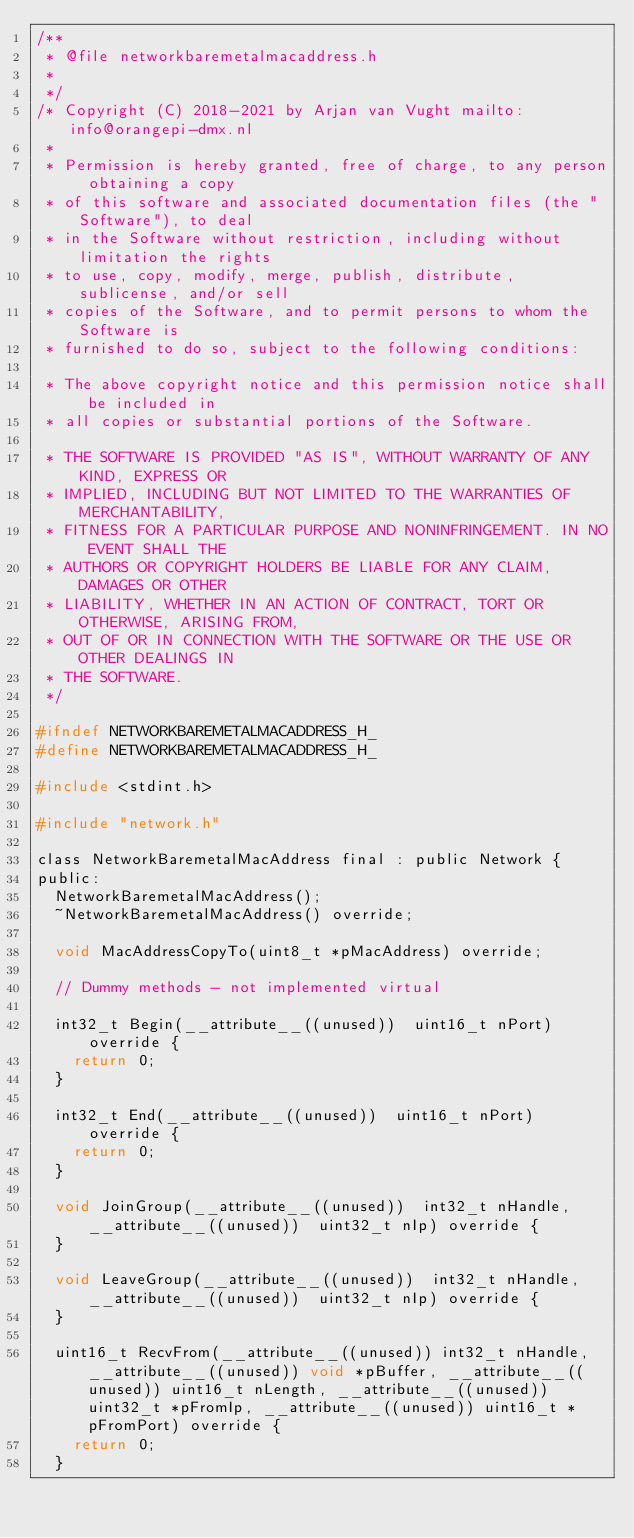<code> <loc_0><loc_0><loc_500><loc_500><_C_>/**
 * @file networkbaremetalmacaddress.h
 *
 */
/* Copyright (C) 2018-2021 by Arjan van Vught mailto:info@orangepi-dmx.nl
 *
 * Permission is hereby granted, free of charge, to any person obtaining a copy
 * of this software and associated documentation files (the "Software"), to deal
 * in the Software without restriction, including without limitation the rights
 * to use, copy, modify, merge, publish, distribute, sublicense, and/or sell
 * copies of the Software, and to permit persons to whom the Software is
 * furnished to do so, subject to the following conditions:

 * The above copyright notice and this permission notice shall be included in
 * all copies or substantial portions of the Software.

 * THE SOFTWARE IS PROVIDED "AS IS", WITHOUT WARRANTY OF ANY KIND, EXPRESS OR
 * IMPLIED, INCLUDING BUT NOT LIMITED TO THE WARRANTIES OF MERCHANTABILITY,
 * FITNESS FOR A PARTICULAR PURPOSE AND NONINFRINGEMENT. IN NO EVENT SHALL THE
 * AUTHORS OR COPYRIGHT HOLDERS BE LIABLE FOR ANY CLAIM, DAMAGES OR OTHER
 * LIABILITY, WHETHER IN AN ACTION OF CONTRACT, TORT OR OTHERWISE, ARISING FROM,
 * OUT OF OR IN CONNECTION WITH THE SOFTWARE OR THE USE OR OTHER DEALINGS IN
 * THE SOFTWARE.
 */

#ifndef NETWORKBAREMETALMACADDRESS_H_
#define NETWORKBAREMETALMACADDRESS_H_

#include <stdint.h>

#include "network.h"

class NetworkBaremetalMacAddress final : public Network {
public:
	NetworkBaremetalMacAddress();
	~NetworkBaremetalMacAddress() override;

	void MacAddressCopyTo(uint8_t *pMacAddress) override;

	// Dummy methods - not implemented virtual

	int32_t Begin(__attribute__((unused))  uint16_t nPort) override {
		return 0;
	}

	int32_t End(__attribute__((unused))  uint16_t nPort) override {
		return 0;
	}

	void JoinGroup(__attribute__((unused))  int32_t nHandle, __attribute__((unused))  uint32_t nIp) override {
	}

	void LeaveGroup(__attribute__((unused))  int32_t nHandle, __attribute__((unused))  uint32_t nIp) override {
	}

	uint16_t RecvFrom(__attribute__((unused)) int32_t nHandle, __attribute__((unused)) void *pBuffer, __attribute__((unused)) uint16_t nLength, __attribute__((unused)) uint32_t *pFromIp, __attribute__((unused)) uint16_t *pFromPort) override {
		return 0;
	}</code> 